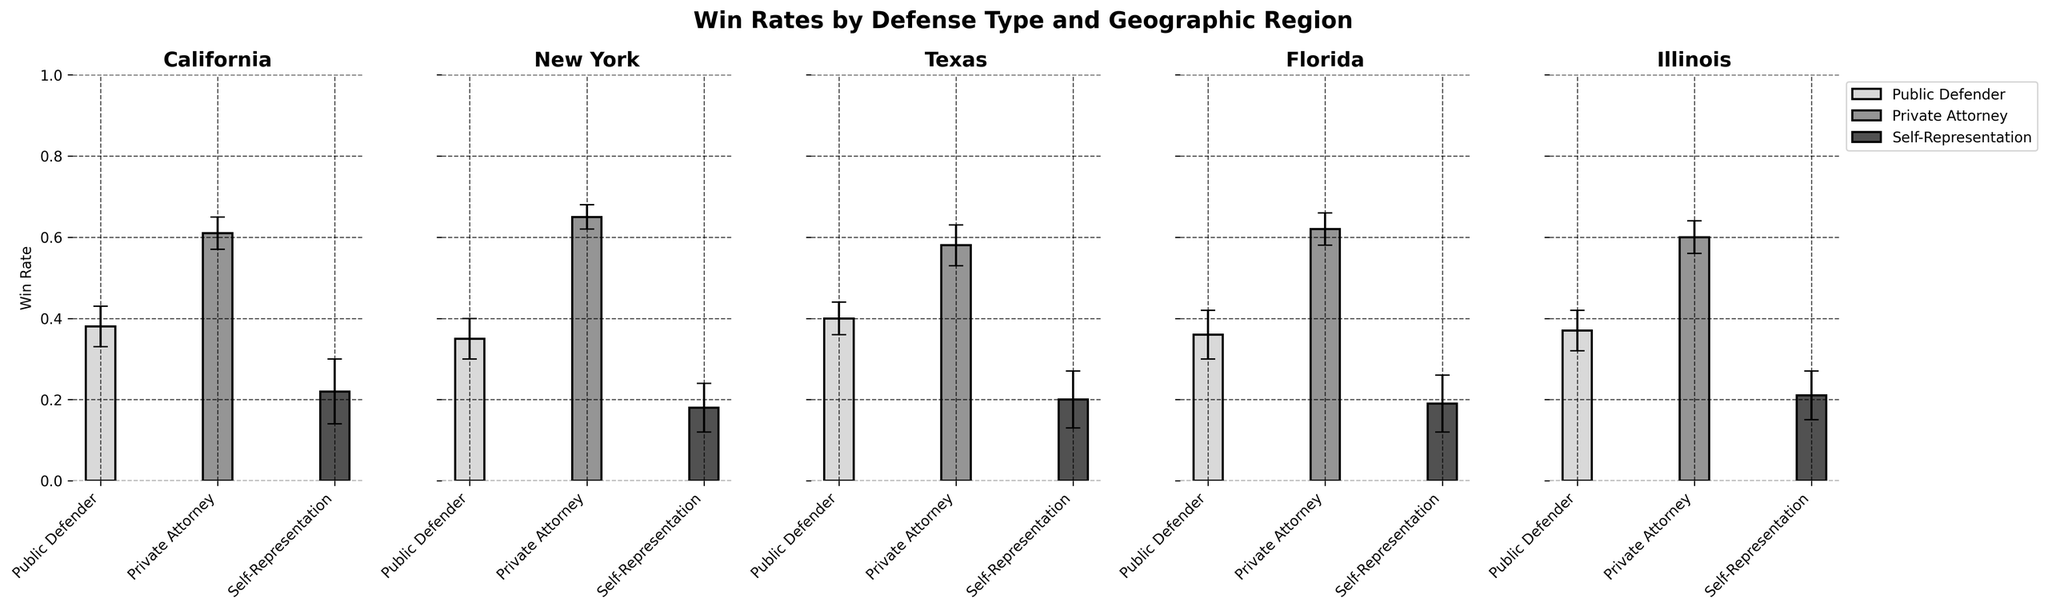What's the title of the figure? The title of the figure is shown at the top of the image and is centralized.
Answer: Win Rates by Defense Type and Geographic Region How many geographic regions are analyzed in the figure? The number of geographic regions can be found by counting the individual titles above each subplot.
Answer: 5 Which defense type has the highest win rate in California? To find this, look at the bars labeled with different defense types in the California subplot and identify the one with the highest value.
Answer: Private Attorney What is the approximate range of win rates for Public Defenders across all regions? Examine the bars labeled "Public Defender" in each subplot to determine the lowest and highest win rates across all geographic regions.
Answer: 0.35 to 0.40 Which region shows the highest win rate for Self-Representation, and what is that win rate? Compare the win rates of Self-Representation in all regions by checking the appropriate bars in each subplot.
Answer: California, 0.22 How do the win rates of Private Attorneys and Public Defenders compare in New York? Look at the New York subplot and compare the heights and y-values of the bars for Private Attorneys and Public Defenders.
Answer: Private Attorney > Public Defender What is the average win rate for Self-Representation across all regions? Sum the win rates for Self-Representation from all subplots and divide by the number of regions (5).
Answer: (0.22 + 0.18 + 0.20 + 0.19 + 0.21) / 5 = 0.20 Is there any defense type whose win rate is consistent across all regions? Check if any bars for a particular defense type have the same height/y-value across all subplots.
Answer: No Which region has the smallest error bar for Public Defenders, and what is its value? Compare the error bars of Public Defenders across all subplots and identify the smallest one.
Answer: Texas, 0.04 